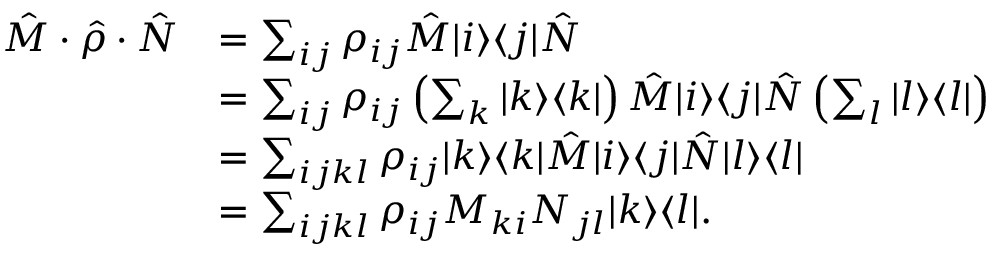Convert formula to latex. <formula><loc_0><loc_0><loc_500><loc_500>\begin{array} { r l } { \quad \hat { M } \cdot \hat { \rho } \cdot \hat { N } } & { = \sum _ { i j } \rho _ { i j } \hat { M } | i \rangle \langle j | \hat { N } } \\ & { = \sum _ { i j } \rho _ { i j } \left ( \sum _ { k } | k \rangle \langle k | \right ) \hat { M } | i \rangle \langle j | \hat { N } \left ( \sum _ { l } | l \rangle \langle l | \right ) } \\ & { = \sum _ { i j k l } \rho _ { i j } | k \rangle \langle k | \hat { M } | i \rangle \langle j | \hat { N } | l \rangle \langle l | } \\ & { = \sum _ { i j k l } \rho _ { i j } M _ { k i } N _ { j l } | k \rangle \langle l | . } \end{array}</formula> 